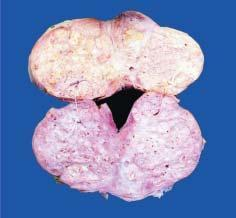does the characteristic feature show soft to firm, grey-white, nodularity with microcystic areas?
Answer the question using a single word or phrase. No 